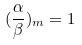<formula> <loc_0><loc_0><loc_500><loc_500>( \frac { \alpha } { \beta } ) _ { m } = 1</formula> 